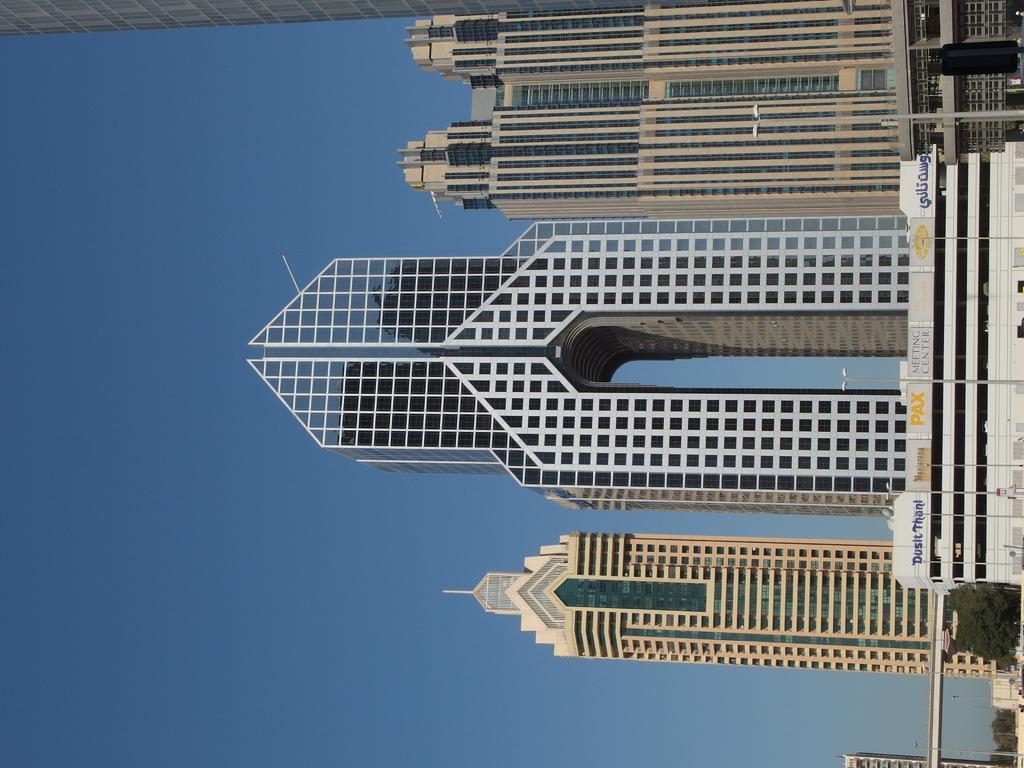What structures are present in the image? There are light poles in the image. What can be seen in the background of the image? There are buildings, trees, and the sky visible in the background of the image. What type of ice can be seen growing on the light poles in the image? There is no ice present on the light poles in the image. How many bushes are visible in the image? There are no bushes mentioned or visible in the image. 